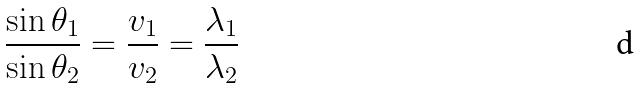Convert formula to latex. <formula><loc_0><loc_0><loc_500><loc_500>\frac { \sin \theta _ { 1 } } { \sin \theta _ { 2 } } = \frac { v _ { 1 } } { v _ { 2 } } = \frac { \lambda _ { 1 } } { \lambda _ { 2 } }</formula> 